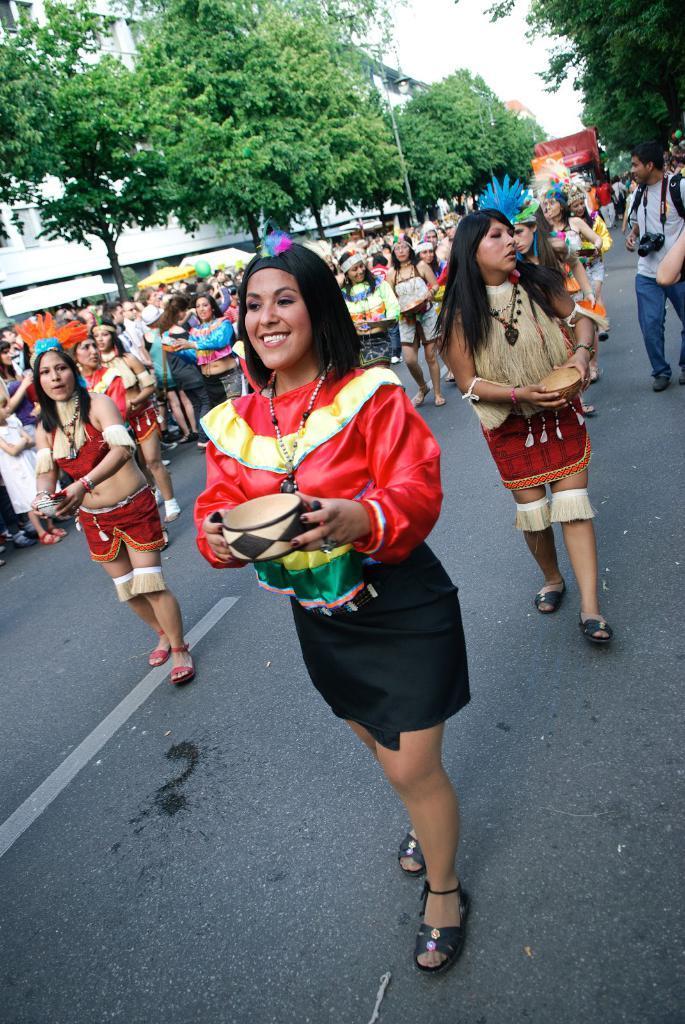Please provide a concise description of this image. This picture is clicked outside the city. In front of the picture, we see a woman in the red dress is holding a bowl in her hands. She is smiling. Behind her, we see people wearing costumes are walking on the road. On the right side, the man in grey T-shirt is walking on the road. He has a camera. In the background, we see a vehicle in red color is moving on the road. There are trees and building in the background. 